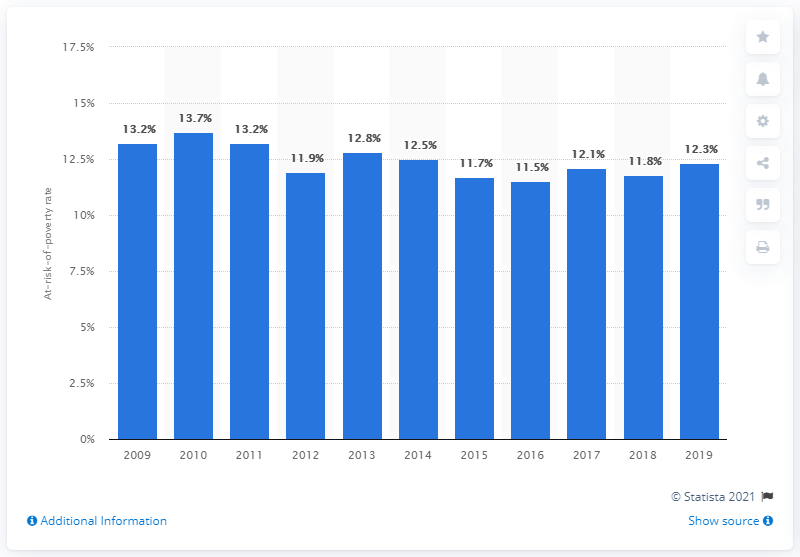Mention a couple of crucial points in this snapshot. In the past few years, the at-risk-of-poverty rate in Finland was 12.1%. According to data from 2019, the at-risk-of-poverty threshold in Finland was 12.3%. 